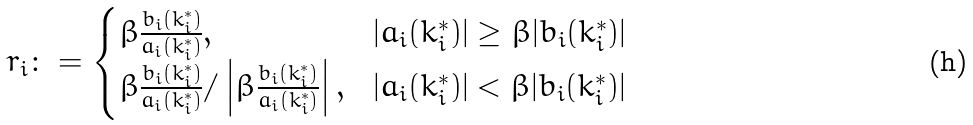<formula> <loc_0><loc_0><loc_500><loc_500>r _ { i } \colon = \begin{cases} \beta \frac { b _ { i } ( k _ { i } ^ { * } ) } { a _ { i } ( k _ { i } ^ { * } ) } , & | a _ { i } ( k _ { i } ^ { * } ) | \geq \beta | b _ { i } ( k _ { i } ^ { * } ) | \\ \beta \frac { b _ { i } ( k _ { i } ^ { * } ) } { a _ { i } ( k _ { i } ^ { * } ) } / \left | \beta \frac { b _ { i } ( k _ { i } ^ { * } ) } { a _ { i } ( k _ { i } ^ { * } ) } \right | , & | a _ { i } ( k _ { i } ^ { * } ) | < \beta | b _ { i } ( k _ { i } ^ { * } ) | \end{cases}</formula> 